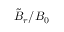Convert formula to latex. <formula><loc_0><loc_0><loc_500><loc_500>\tilde { B } _ { r } / B _ { 0 }</formula> 